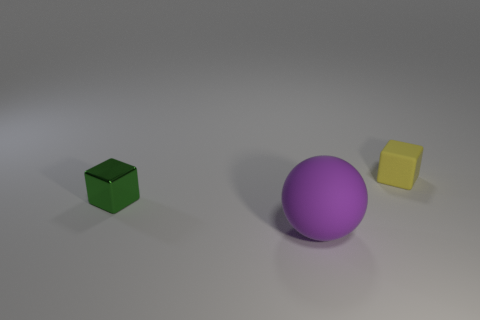How many objects are either purple rubber things or tiny objects on the right side of the metallic thing?
Your answer should be very brief. 2. What size is the yellow thing that is made of the same material as the purple thing?
Make the answer very short. Small. Is the number of purple spheres that are in front of the ball greater than the number of small blue rubber blocks?
Your answer should be very brief. No. There is a thing that is both right of the tiny metallic cube and to the left of the yellow matte block; what is its size?
Offer a very short reply. Large. What material is the tiny green thing that is the same shape as the yellow rubber thing?
Offer a terse response. Metal. Is the size of the cube left of the rubber ball the same as the large rubber object?
Your response must be concise. No. What color is the object that is to the right of the green object and behind the purple rubber thing?
Offer a very short reply. Yellow. There is a tiny thing that is to the left of the small yellow matte thing; what number of tiny cubes are in front of it?
Provide a short and direct response. 0. Do the yellow object and the green metallic object have the same shape?
Give a very brief answer. Yes. Is there any other thing that is the same color as the metal cube?
Offer a terse response. No. 